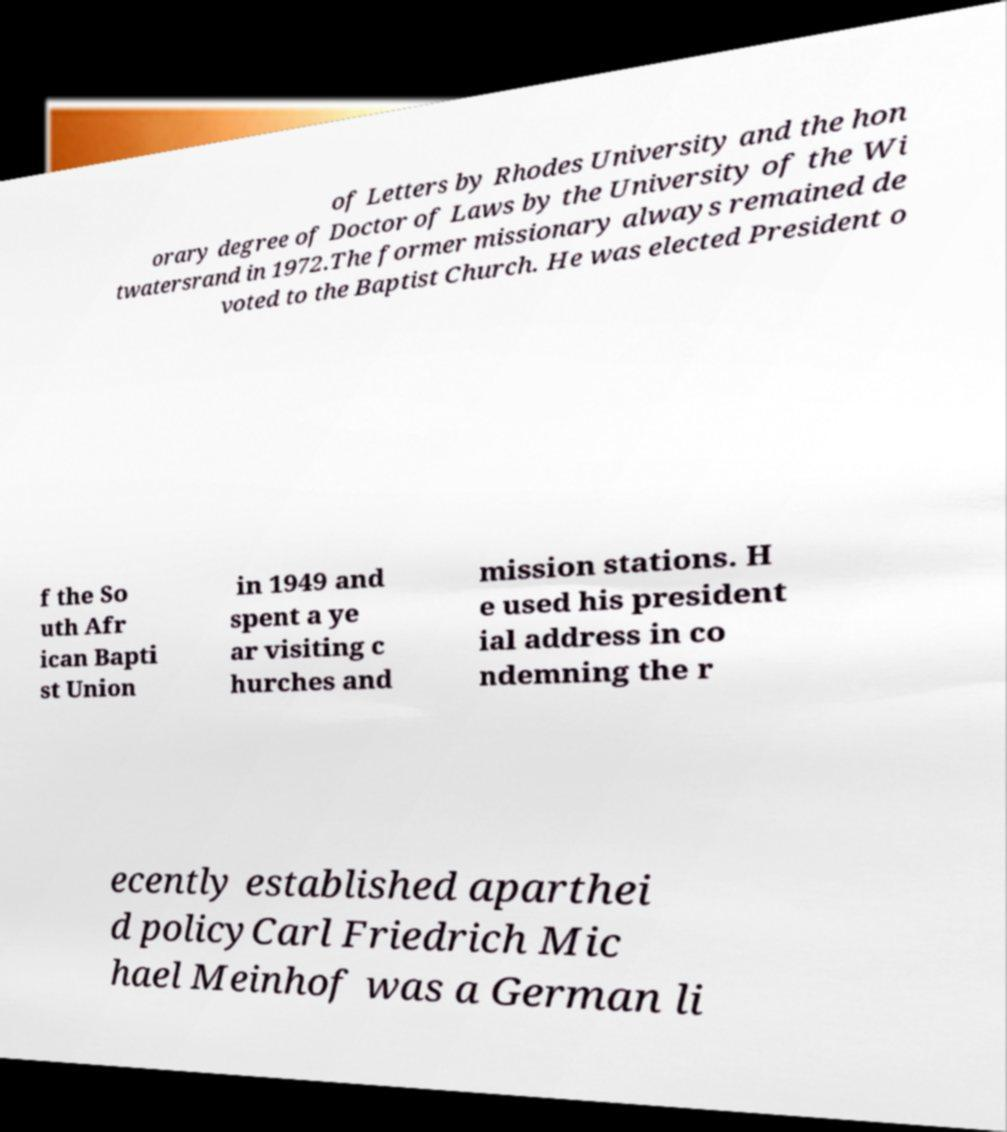Can you read and provide the text displayed in the image?This photo seems to have some interesting text. Can you extract and type it out for me? of Letters by Rhodes University and the hon orary degree of Doctor of Laws by the University of the Wi twatersrand in 1972.The former missionary always remained de voted to the Baptist Church. He was elected President o f the So uth Afr ican Bapti st Union in 1949 and spent a ye ar visiting c hurches and mission stations. H e used his president ial address in co ndemning the r ecently established aparthei d policyCarl Friedrich Mic hael Meinhof was a German li 